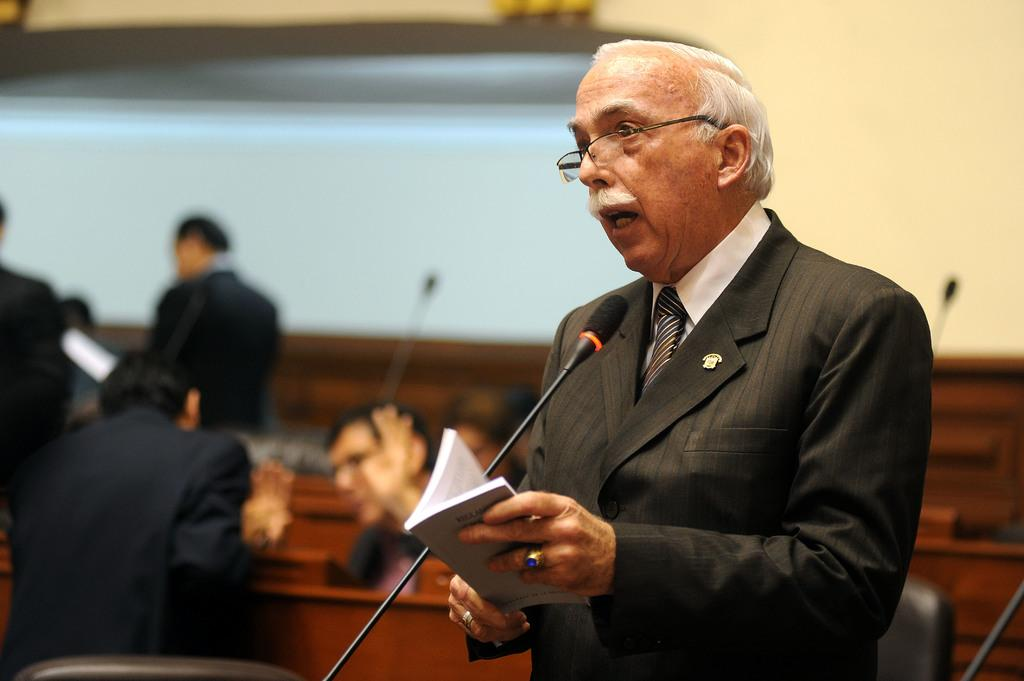What is the main subject of the image? There is a man standing in the image. What is the man wearing? The man is wearing a coat. What object is in front of the man? There is a mic in front of the man. What is the man holding in his hand? The man is holding a book in his hand. Are there any other people present in the image? Yes, there are other men present behind the man. What does the man's aunt say about his hearing in the image? There is no mention of an aunt or hearing in the image; it only shows a man standing with a mic, a coat, a book, and other men behind him. 